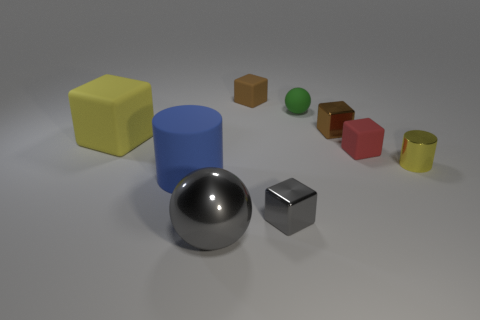Subtract all green balls. How many brown blocks are left? 2 Subtract 1 cubes. How many cubes are left? 4 Subtract all gray cubes. How many cubes are left? 4 Subtract all yellow cubes. How many cubes are left? 4 Subtract all purple cubes. Subtract all purple cylinders. How many cubes are left? 5 Subtract all blocks. How many objects are left? 4 Add 4 red spheres. How many red spheres exist? 4 Subtract 0 purple spheres. How many objects are left? 9 Subtract all large things. Subtract all large shiny balls. How many objects are left? 5 Add 1 big blue cylinders. How many big blue cylinders are left? 2 